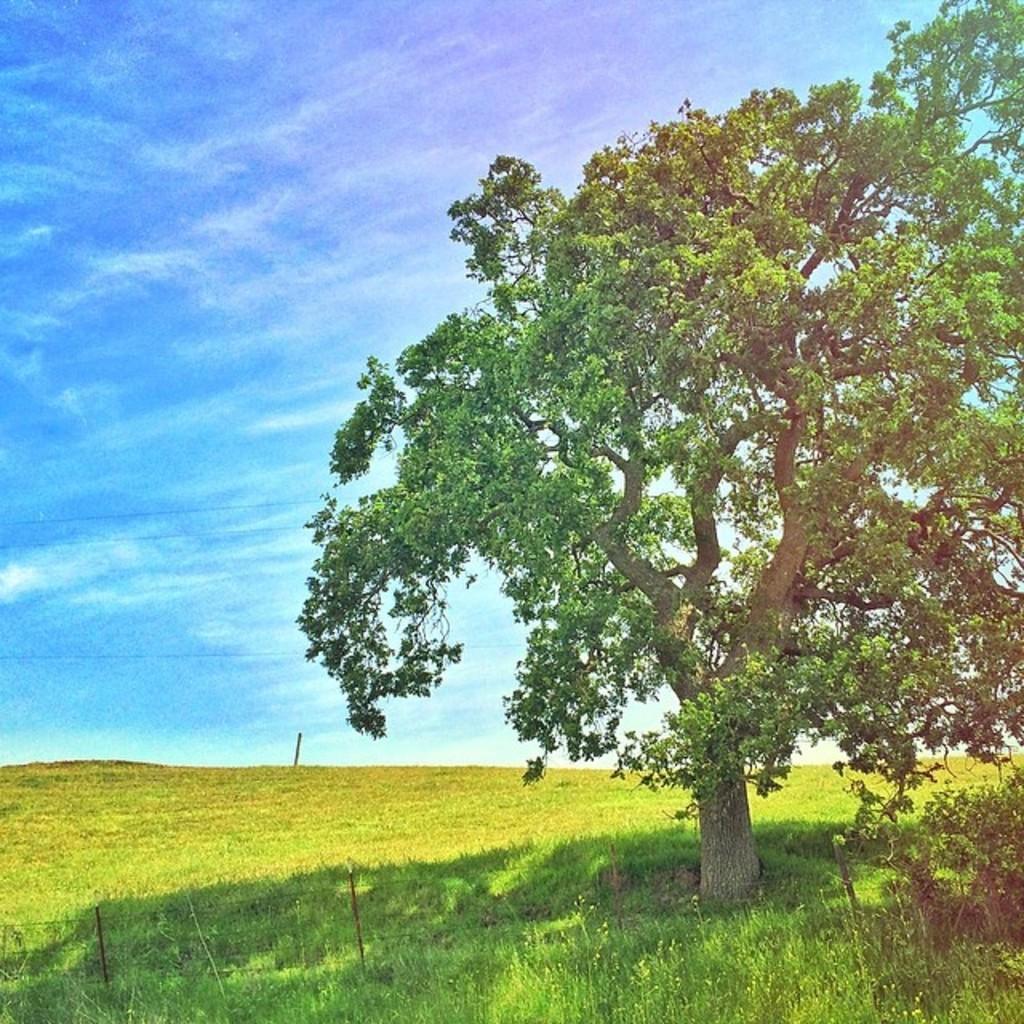In one or two sentences, can you explain what this image depicts? In the image we can see a tree, plant, grass, blue sky, small pole and fence wires. 